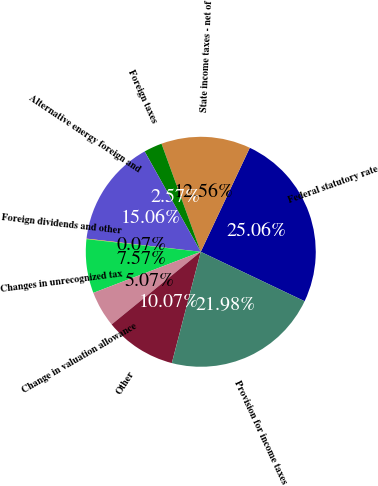Convert chart to OTSL. <chart><loc_0><loc_0><loc_500><loc_500><pie_chart><fcel>Federal statutory rate<fcel>State income taxes - net of<fcel>Foreign taxes<fcel>Alternative energy foreign and<fcel>Foreign dividends and other<fcel>Changes in unrecognized tax<fcel>Change in valuation allowance<fcel>Other<fcel>Provision for income taxes<nl><fcel>25.06%<fcel>12.56%<fcel>2.57%<fcel>15.06%<fcel>0.07%<fcel>7.57%<fcel>5.07%<fcel>10.07%<fcel>21.98%<nl></chart> 